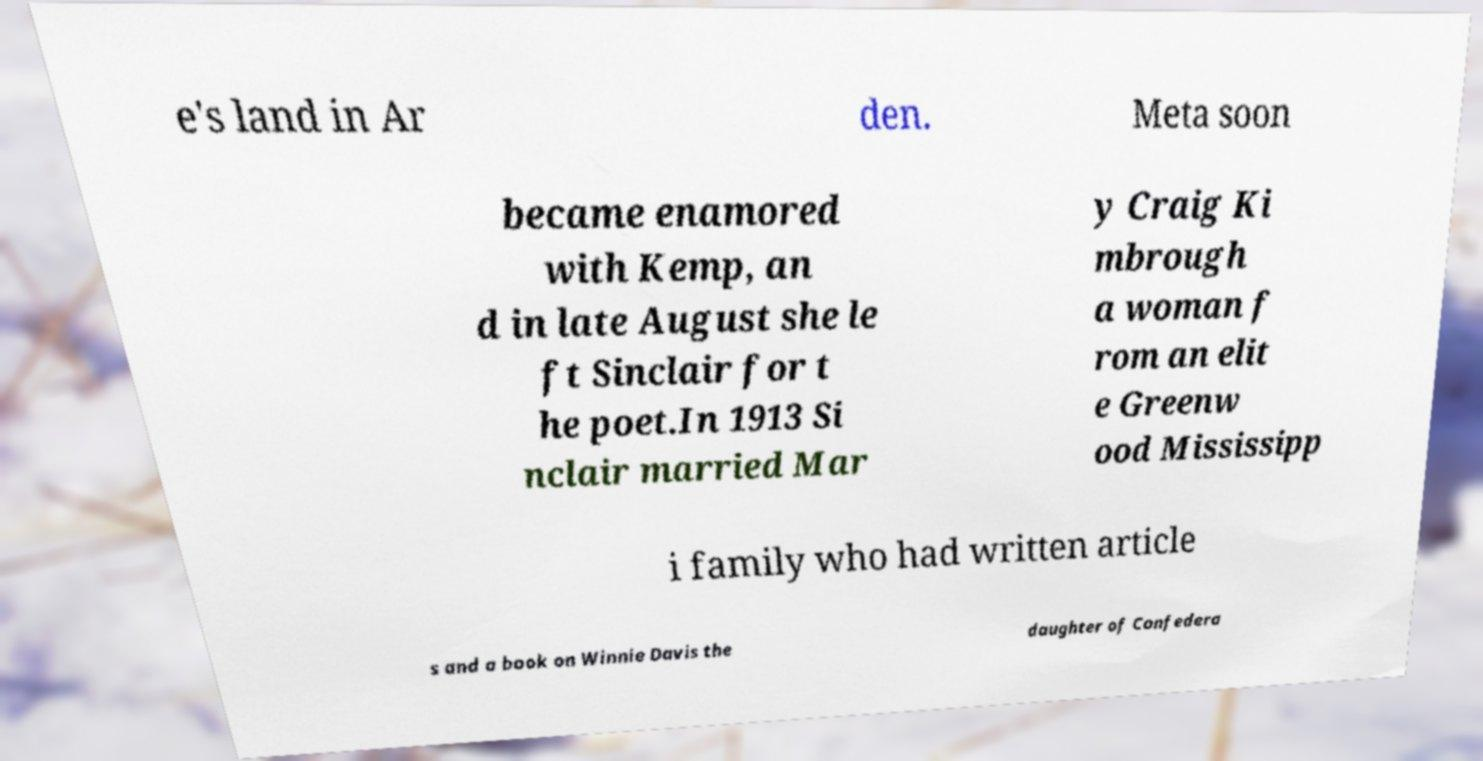Can you accurately transcribe the text from the provided image for me? e's land in Ar den. Meta soon became enamored with Kemp, an d in late August she le ft Sinclair for t he poet.In 1913 Si nclair married Mar y Craig Ki mbrough a woman f rom an elit e Greenw ood Mississipp i family who had written article s and a book on Winnie Davis the daughter of Confedera 